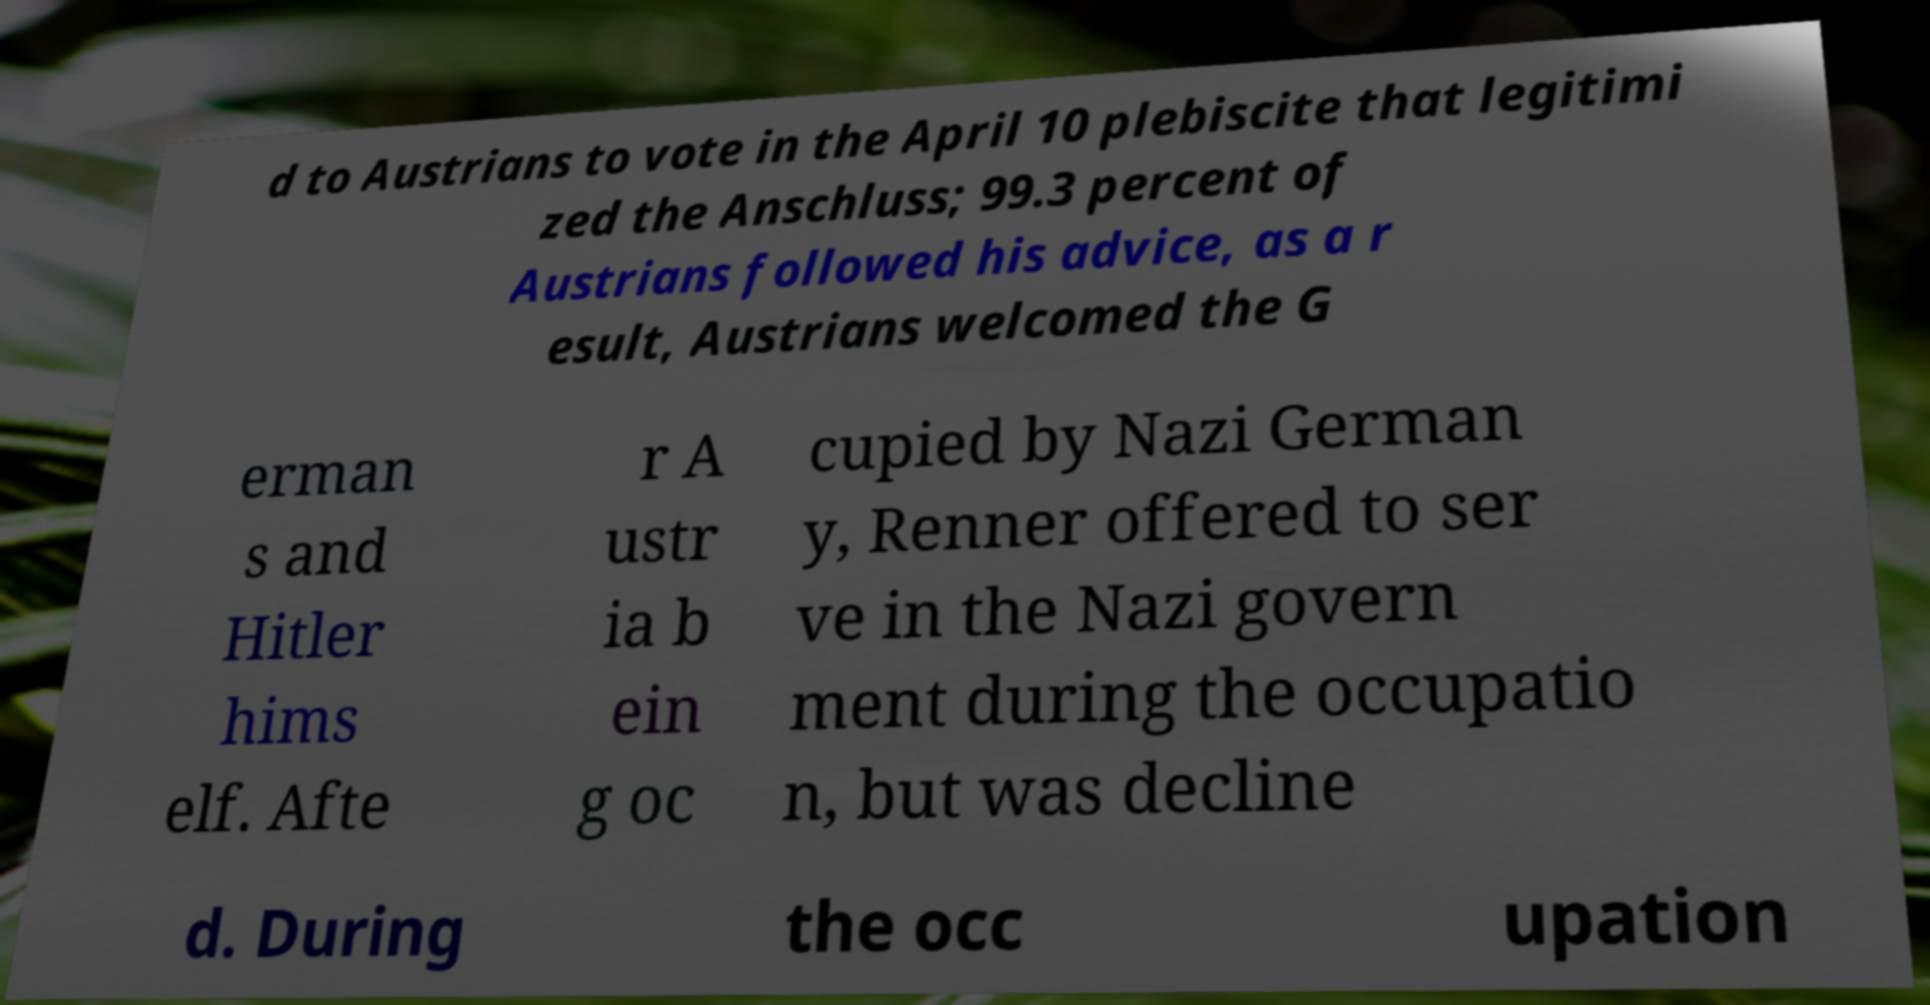Can you read and provide the text displayed in the image?This photo seems to have some interesting text. Can you extract and type it out for me? d to Austrians to vote in the April 10 plebiscite that legitimi zed the Anschluss; 99.3 percent of Austrians followed his advice, as a r esult, Austrians welcomed the G erman s and Hitler hims elf. Afte r A ustr ia b ein g oc cupied by Nazi German y, Renner offered to ser ve in the Nazi govern ment during the occupatio n, but was decline d. During the occ upation 